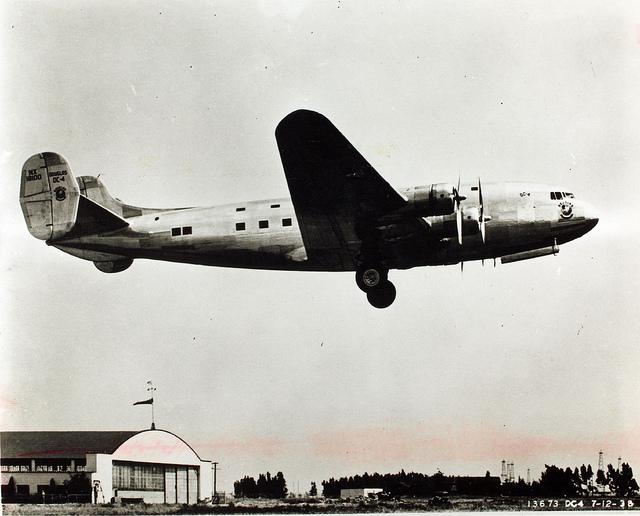Is this a new or old picture?
Short answer required. Old. Is the plane going to land?
Give a very brief answer. Yes. What is the photograph dated?
Short answer required. 7-12-35. 